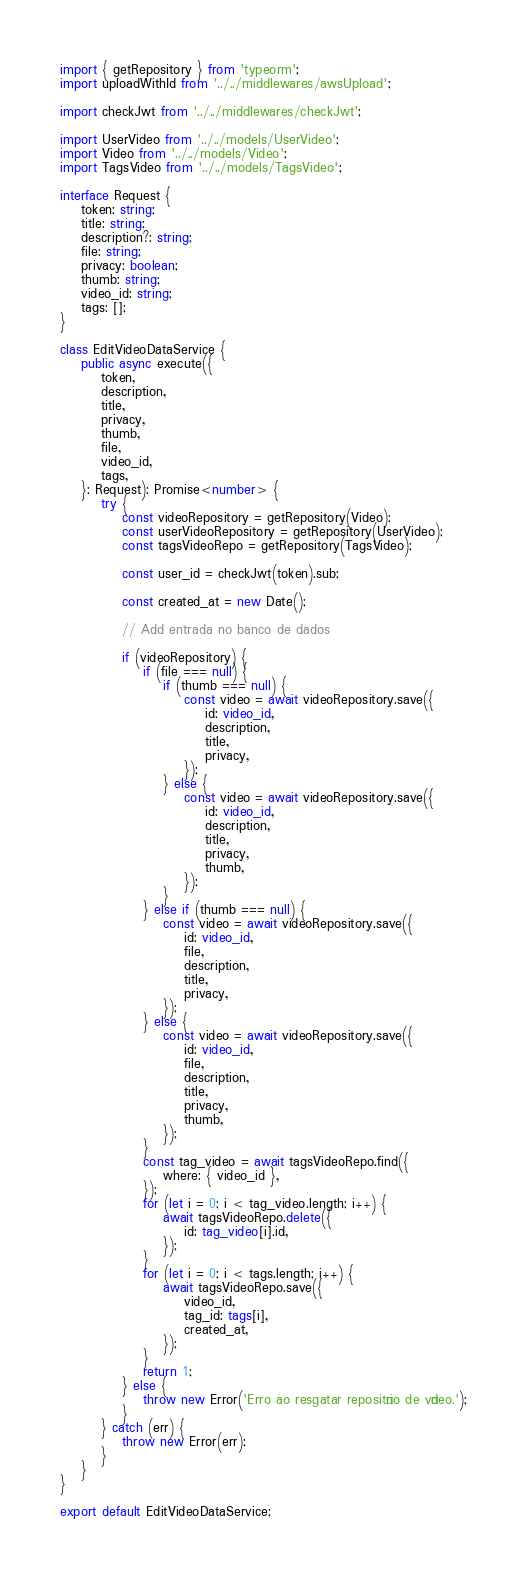Convert code to text. <code><loc_0><loc_0><loc_500><loc_500><_TypeScript_>import { getRepository } from 'typeorm';
import uploadWithId from '../../middlewares/awsUpload';

import checkJwt from '../../middlewares/checkJwt';

import UserVideo from '../../models/UserVideo';
import Video from '../../models/Video';
import TagsVideo from '../../models/TagsVideo';

interface Request {
	token: string;
	title: string;
	description?: string;
	file: string;
	privacy: boolean;
	thumb: string;
	video_id: string;
	tags: [];
}

class EditVideoDataService {
	public async execute({
		token,
		description,
		title,
		privacy,
		thumb,
		file,
		video_id,
		tags,
	}: Request): Promise<number> {
		try {
			const videoRepository = getRepository(Video);
			const userVideoRepository = getRepository(UserVideo);
			const tagsVideoRepo = getRepository(TagsVideo);

			const user_id = checkJwt(token).sub;

			const created_at = new Date();

			// Add entrada no banco de dados

			if (videoRepository) {
				if (file === null) {
					if (thumb === null) {
						const video = await videoRepository.save({
							id: video_id,
							description,
							title,
							privacy,
						});
					} else {
						const video = await videoRepository.save({
							id: video_id,
							description,
							title,
							privacy,
							thumb,
						});
					}
				} else if (thumb === null) {
					const video = await videoRepository.save({
						id: video_id,
						file,
						description,
						title,
						privacy,
					});
				} else {
					const video = await videoRepository.save({
						id: video_id,
						file,
						description,
						title,
						privacy,
						thumb,
					});
				}
				const tag_video = await tagsVideoRepo.find({
					where: { video_id },
				});
				for (let i = 0; i < tag_video.length; i++) {
					await tagsVideoRepo.delete({
						id: tag_video[i].id,
					});
				}
				for (let i = 0; i < tags.length; i++) {
					await tagsVideoRepo.save({
						video_id,
						tag_id: tags[i],
						created_at,
					});
				}
				return 1;
			} else {
				throw new Error('Erro ao resgatar repositório de vídeo.');
			}
		} catch (err) {
			throw new Error(err);
		}
	}
}

export default EditVideoDataService;
</code> 